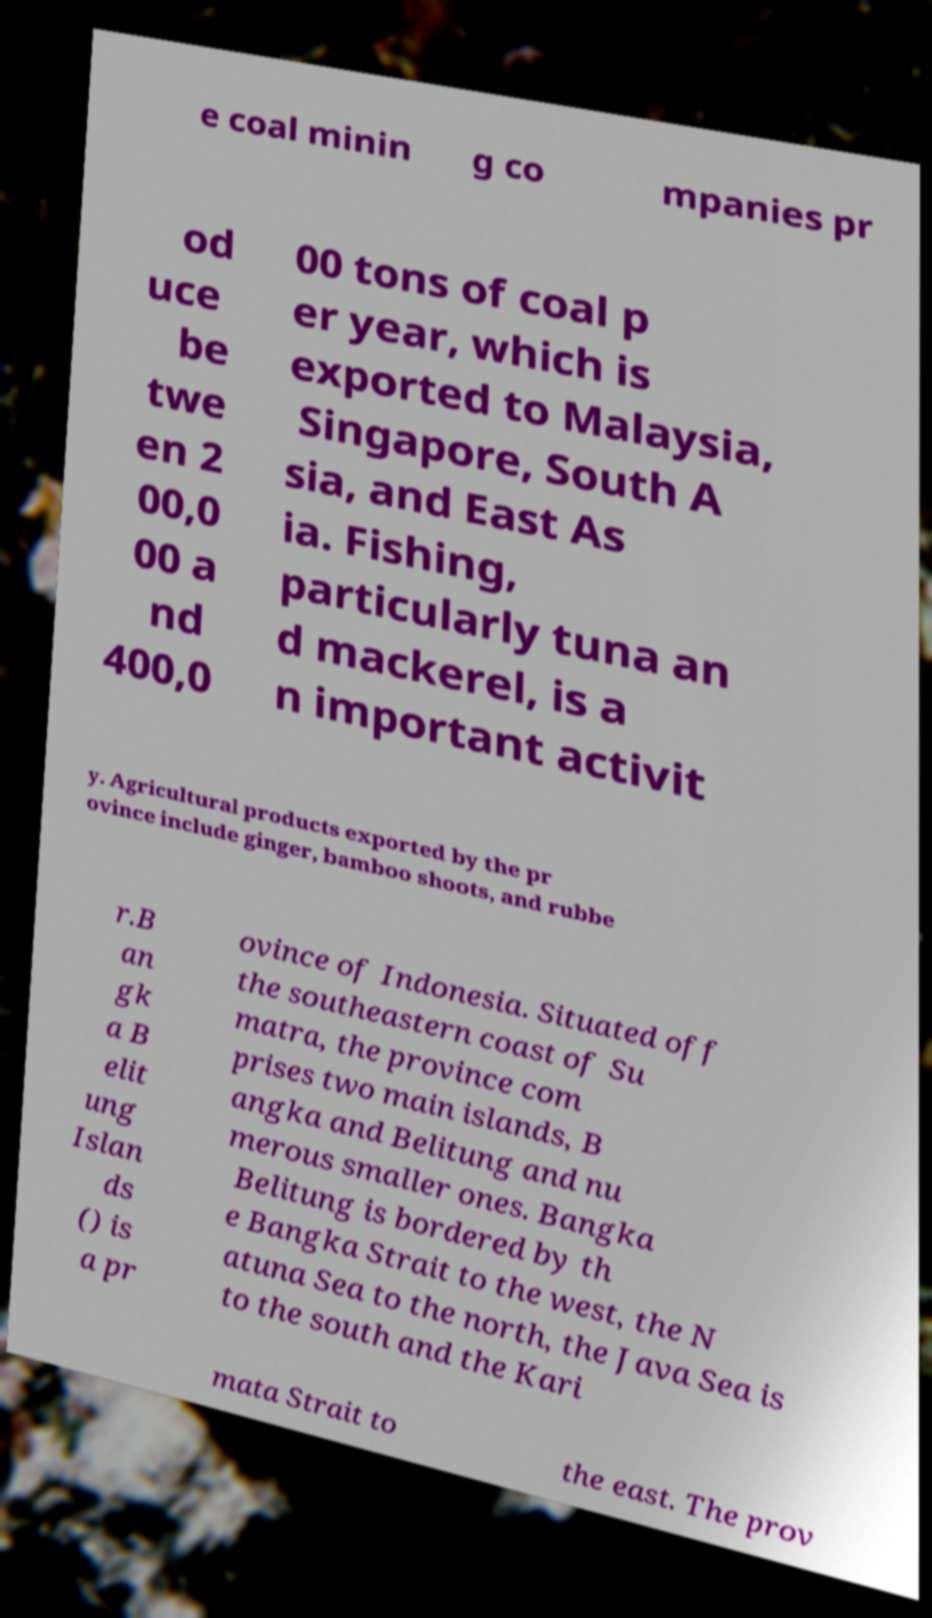Could you assist in decoding the text presented in this image and type it out clearly? e coal minin g co mpanies pr od uce be twe en 2 00,0 00 a nd 400,0 00 tons of coal p er year, which is exported to Malaysia, Singapore, South A sia, and East As ia. Fishing, particularly tuna an d mackerel, is a n important activit y. Agricultural products exported by the pr ovince include ginger, bamboo shoots, and rubbe r.B an gk a B elit ung Islan ds () is a pr ovince of Indonesia. Situated off the southeastern coast of Su matra, the province com prises two main islands, B angka and Belitung and nu merous smaller ones. Bangka Belitung is bordered by th e Bangka Strait to the west, the N atuna Sea to the north, the Java Sea is to the south and the Kari mata Strait to the east. The prov 